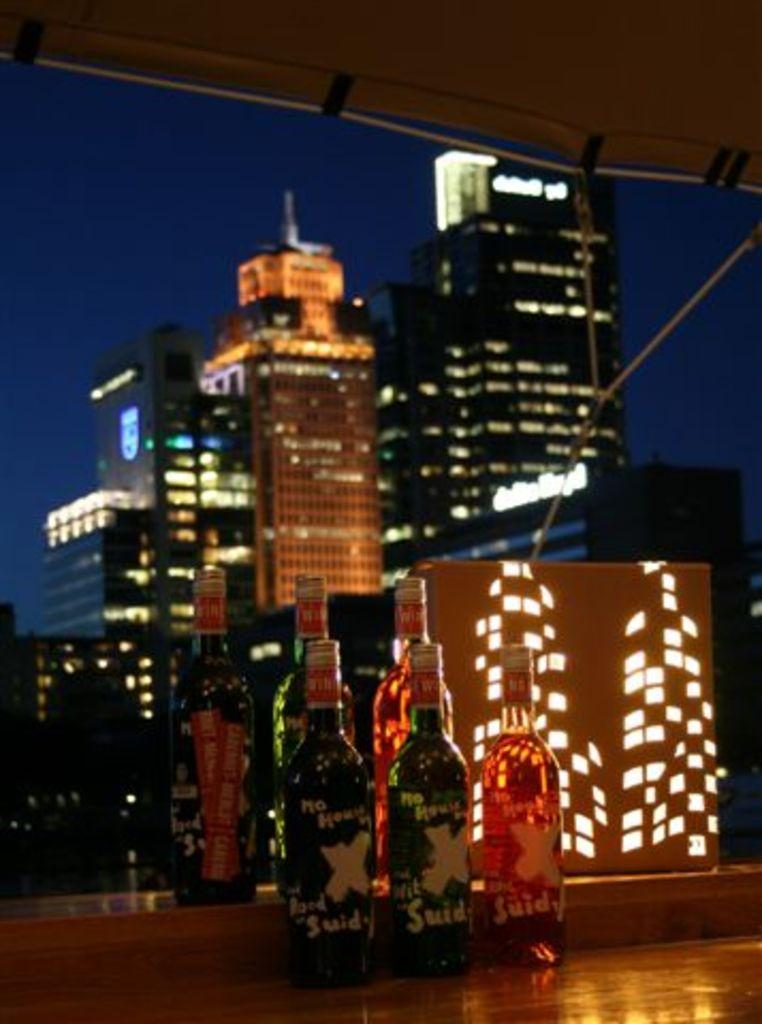Provide a one-sentence caption for the provided image. Bottles of No House Suid next to a window overlooking a city. 